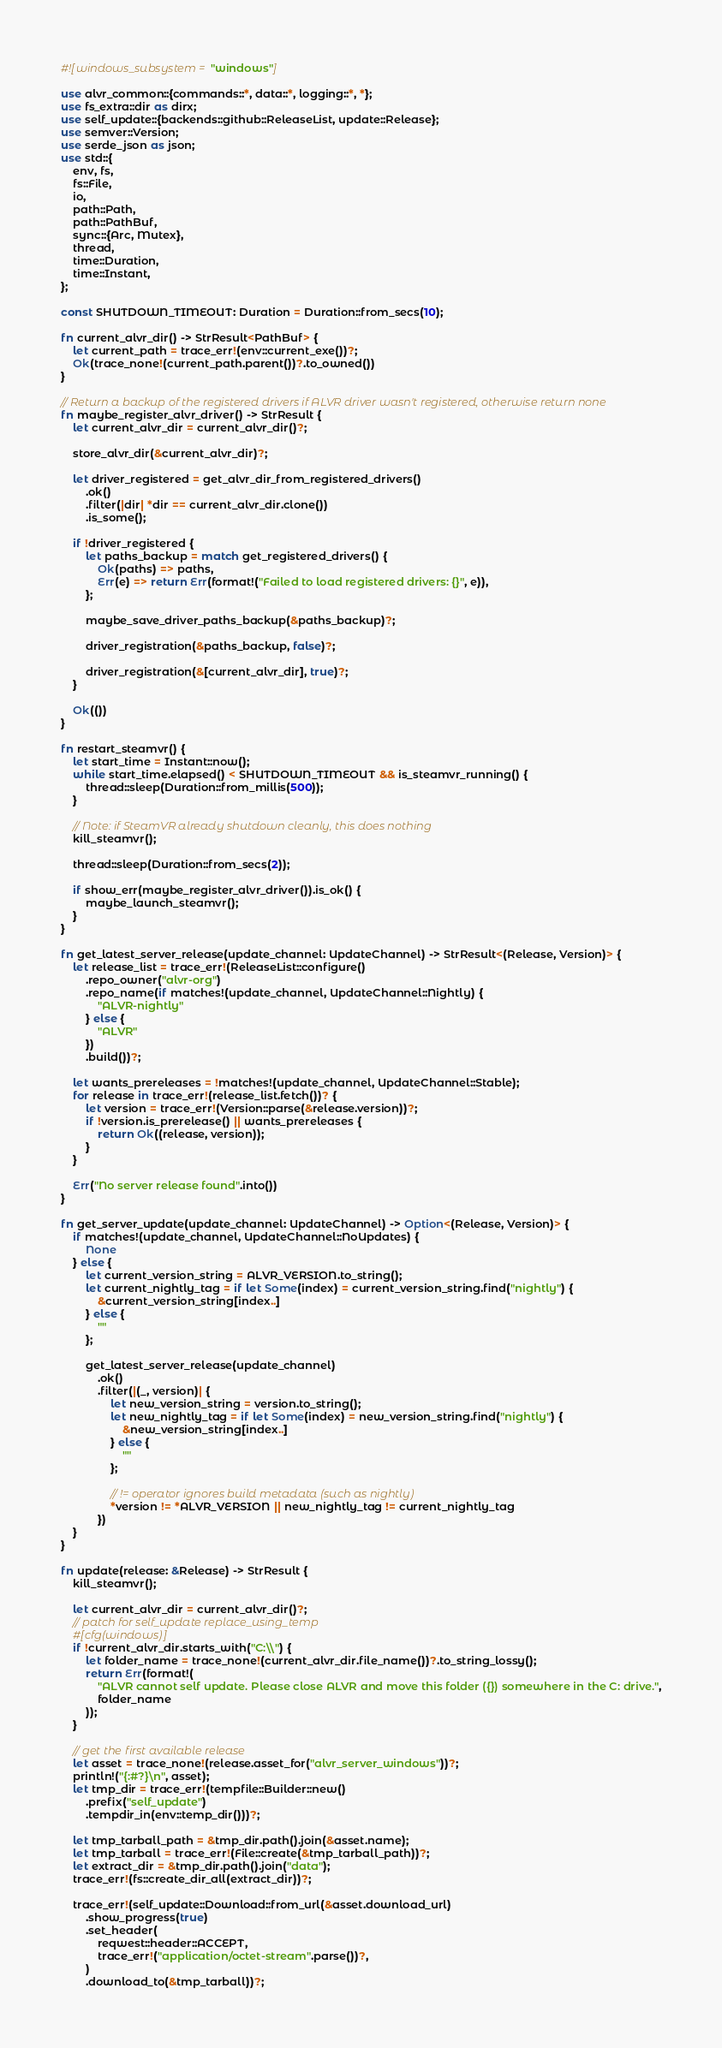<code> <loc_0><loc_0><loc_500><loc_500><_Rust_>#![windows_subsystem = "windows"]

use alvr_common::{commands::*, data::*, logging::*, *};
use fs_extra::dir as dirx;
use self_update::{backends::github::ReleaseList, update::Release};
use semver::Version;
use serde_json as json;
use std::{
    env, fs,
    fs::File,
    io,
    path::Path,
    path::PathBuf,
    sync::{Arc, Mutex},
    thread,
    time::Duration,
    time::Instant,
};

const SHUTDOWN_TIMEOUT: Duration = Duration::from_secs(10);

fn current_alvr_dir() -> StrResult<PathBuf> {
    let current_path = trace_err!(env::current_exe())?;
    Ok(trace_none!(current_path.parent())?.to_owned())
}

// Return a backup of the registered drivers if ALVR driver wasn't registered, otherwise return none
fn maybe_register_alvr_driver() -> StrResult {
    let current_alvr_dir = current_alvr_dir()?;

    store_alvr_dir(&current_alvr_dir)?;

    let driver_registered = get_alvr_dir_from_registered_drivers()
        .ok()
        .filter(|dir| *dir == current_alvr_dir.clone())
        .is_some();

    if !driver_registered {
        let paths_backup = match get_registered_drivers() {
            Ok(paths) => paths,
            Err(e) => return Err(format!("Failed to load registered drivers: {}", e)),
        };

        maybe_save_driver_paths_backup(&paths_backup)?;

        driver_registration(&paths_backup, false)?;

        driver_registration(&[current_alvr_dir], true)?;
    }

    Ok(())
}

fn restart_steamvr() {
    let start_time = Instant::now();
    while start_time.elapsed() < SHUTDOWN_TIMEOUT && is_steamvr_running() {
        thread::sleep(Duration::from_millis(500));
    }

    // Note: if SteamVR already shutdown cleanly, this does nothing
    kill_steamvr();

    thread::sleep(Duration::from_secs(2));

    if show_err(maybe_register_alvr_driver()).is_ok() {
        maybe_launch_steamvr();
    }
}

fn get_latest_server_release(update_channel: UpdateChannel) -> StrResult<(Release, Version)> {
    let release_list = trace_err!(ReleaseList::configure()
        .repo_owner("alvr-org")
        .repo_name(if matches!(update_channel, UpdateChannel::Nightly) {
            "ALVR-nightly"
        } else {
            "ALVR"
        })
        .build())?;

    let wants_prereleases = !matches!(update_channel, UpdateChannel::Stable);
    for release in trace_err!(release_list.fetch())? {
        let version = trace_err!(Version::parse(&release.version))?;
        if !version.is_prerelease() || wants_prereleases {
            return Ok((release, version));
        }
    }

    Err("No server release found".into())
}

fn get_server_update(update_channel: UpdateChannel) -> Option<(Release, Version)> {
    if matches!(update_channel, UpdateChannel::NoUpdates) {
        None
    } else {
        let current_version_string = ALVR_VERSION.to_string();
        let current_nightly_tag = if let Some(index) = current_version_string.find("nightly") {
            &current_version_string[index..]
        } else {
            ""
        };

        get_latest_server_release(update_channel)
            .ok()
            .filter(|(_, version)| {
                let new_version_string = version.to_string();
                let new_nightly_tag = if let Some(index) = new_version_string.find("nightly") {
                    &new_version_string[index..]
                } else {
                    ""
                };

                // != operator ignores build metadata (such as nightly)
                *version != *ALVR_VERSION || new_nightly_tag != current_nightly_tag
            })
    }
}

fn update(release: &Release) -> StrResult {
    kill_steamvr();

    let current_alvr_dir = current_alvr_dir()?;
    // patch for self_update replace_using_temp
    #[cfg(windows)]
    if !current_alvr_dir.starts_with("C:\\") {
        let folder_name = trace_none!(current_alvr_dir.file_name())?.to_string_lossy();
        return Err(format!(
            "ALVR cannot self update. Please close ALVR and move this folder ({}) somewhere in the C: drive.",
            folder_name
        ));
    }

    // get the first available release
    let asset = trace_none!(release.asset_for("alvr_server_windows"))?;
    println!("{:#?}\n", asset);
    let tmp_dir = trace_err!(tempfile::Builder::new()
        .prefix("self_update")
        .tempdir_in(env::temp_dir()))?;

    let tmp_tarball_path = &tmp_dir.path().join(&asset.name);
    let tmp_tarball = trace_err!(File::create(&tmp_tarball_path))?;
    let extract_dir = &tmp_dir.path().join("data");
    trace_err!(fs::create_dir_all(extract_dir))?;

    trace_err!(self_update::Download::from_url(&asset.download_url)
        .show_progress(true)
        .set_header(
            reqwest::header::ACCEPT,
            trace_err!("application/octet-stream".parse())?,
        )
        .download_to(&tmp_tarball))?;</code> 